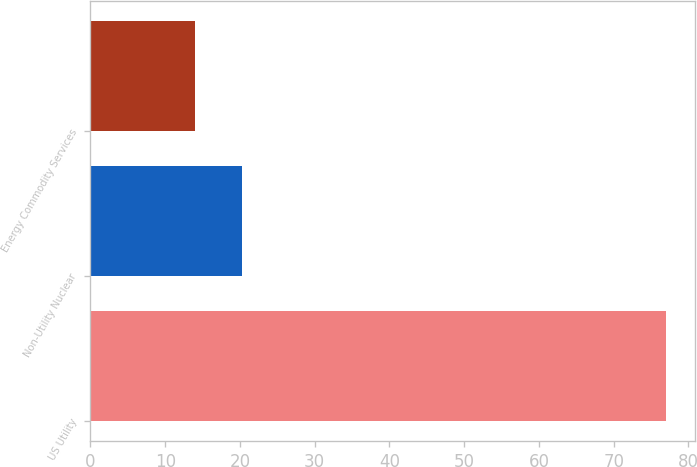<chart> <loc_0><loc_0><loc_500><loc_500><bar_chart><fcel>US Utility<fcel>Non-Utility Nuclear<fcel>Energy Commodity Services<nl><fcel>77<fcel>20.3<fcel>14<nl></chart> 